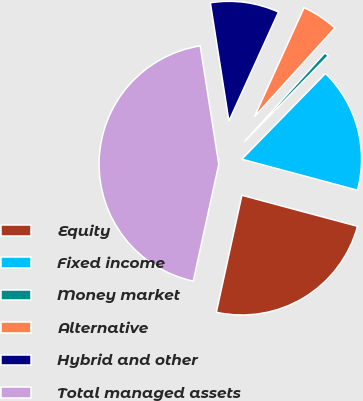<chart> <loc_0><loc_0><loc_500><loc_500><pie_chart><fcel>Equity<fcel>Fixed income<fcel>Money market<fcel>Alternative<fcel>Hybrid and other<fcel>Total managed assets<nl><fcel>24.25%<fcel>16.86%<fcel>0.58%<fcel>4.93%<fcel>9.28%<fcel>44.09%<nl></chart> 